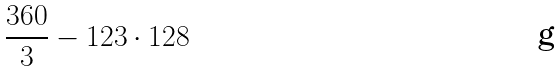<formula> <loc_0><loc_0><loc_500><loc_500>\frac { 3 6 0 } { 3 } - 1 2 3 \cdot 1 2 8</formula> 